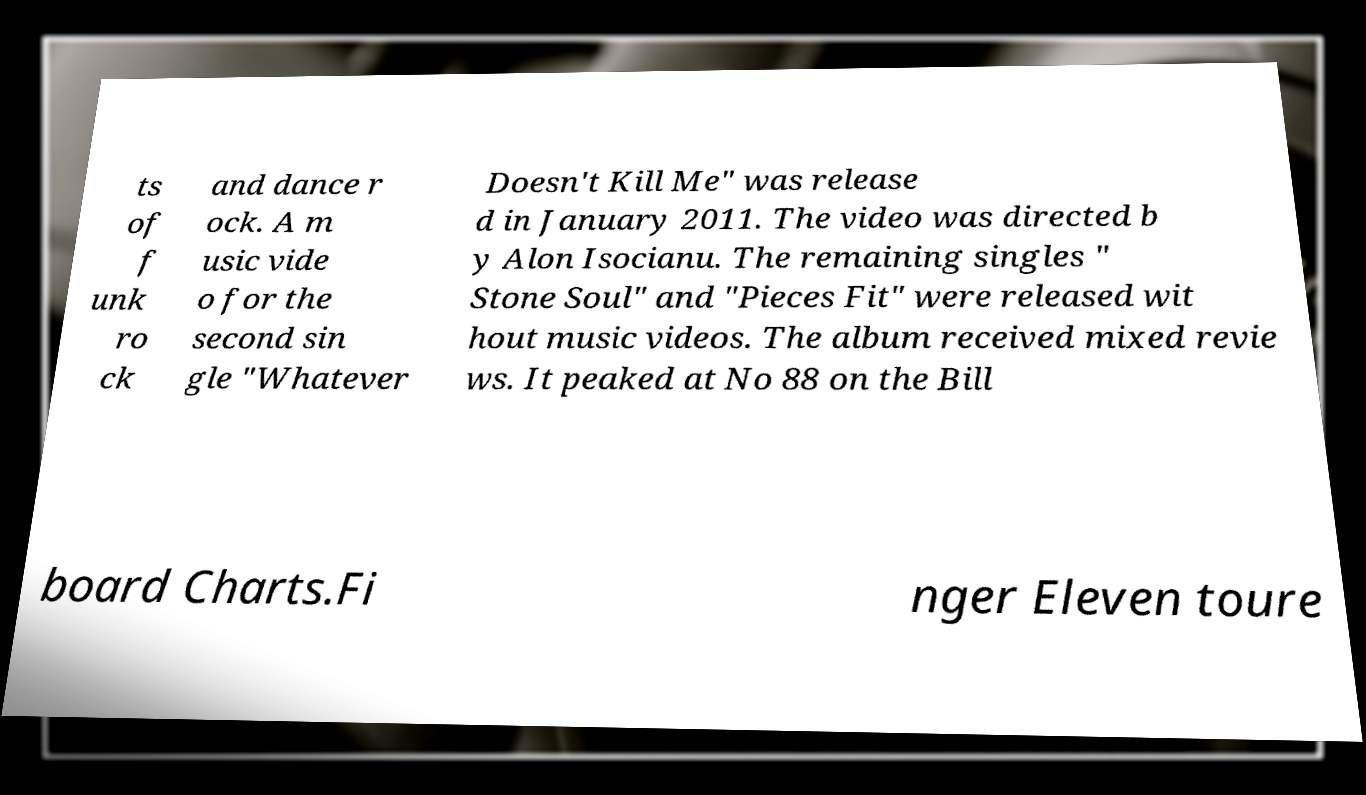Can you read and provide the text displayed in the image?This photo seems to have some interesting text. Can you extract and type it out for me? ts of f unk ro ck and dance r ock. A m usic vide o for the second sin gle "Whatever Doesn't Kill Me" was release d in January 2011. The video was directed b y Alon Isocianu. The remaining singles " Stone Soul" and "Pieces Fit" were released wit hout music videos. The album received mixed revie ws. It peaked at No 88 on the Bill board Charts.Fi nger Eleven toure 